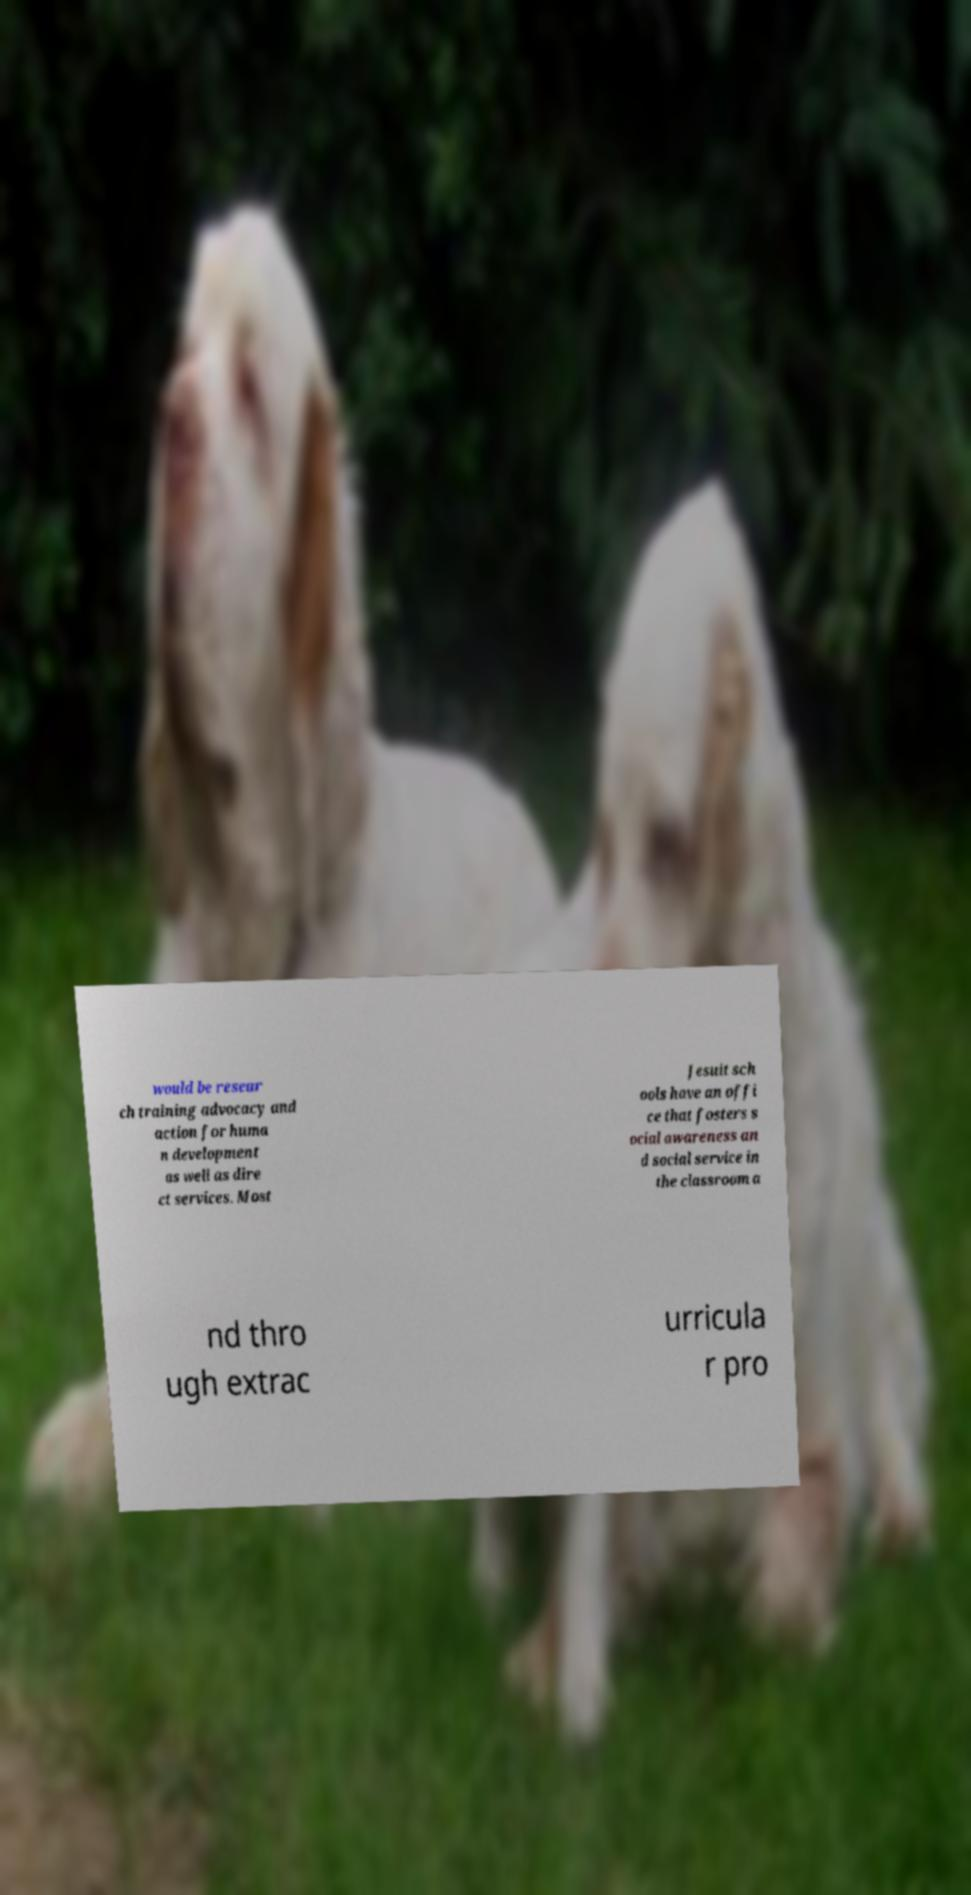Could you assist in decoding the text presented in this image and type it out clearly? would be resear ch training advocacy and action for huma n development as well as dire ct services. Most Jesuit sch ools have an offi ce that fosters s ocial awareness an d social service in the classroom a nd thro ugh extrac urricula r pro 